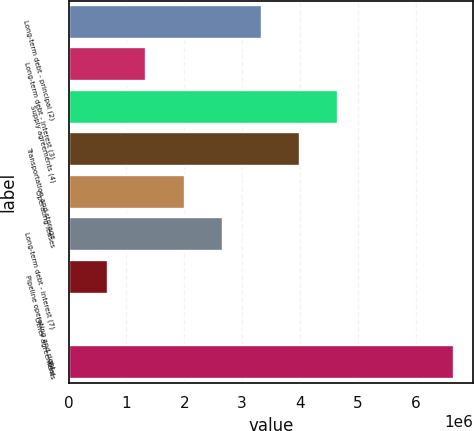<chart> <loc_0><loc_0><loc_500><loc_500><bar_chart><fcel>Long-term debt - principal (2)<fcel>Long-term debt - interest (3)<fcel>Supply agreements (4)<fcel>Transportation and storage<fcel>Operating leases<fcel>Long-term debt - interest (7)<fcel>Pipeline operating and right<fcel>Other agreements<fcel>Total<nl><fcel>3.3348e+06<fcel>1.34221e+06<fcel>4.66319e+06<fcel>3.999e+06<fcel>2.00641e+06<fcel>2.67061e+06<fcel>678019<fcel>13823<fcel>6.65578e+06<nl></chart> 